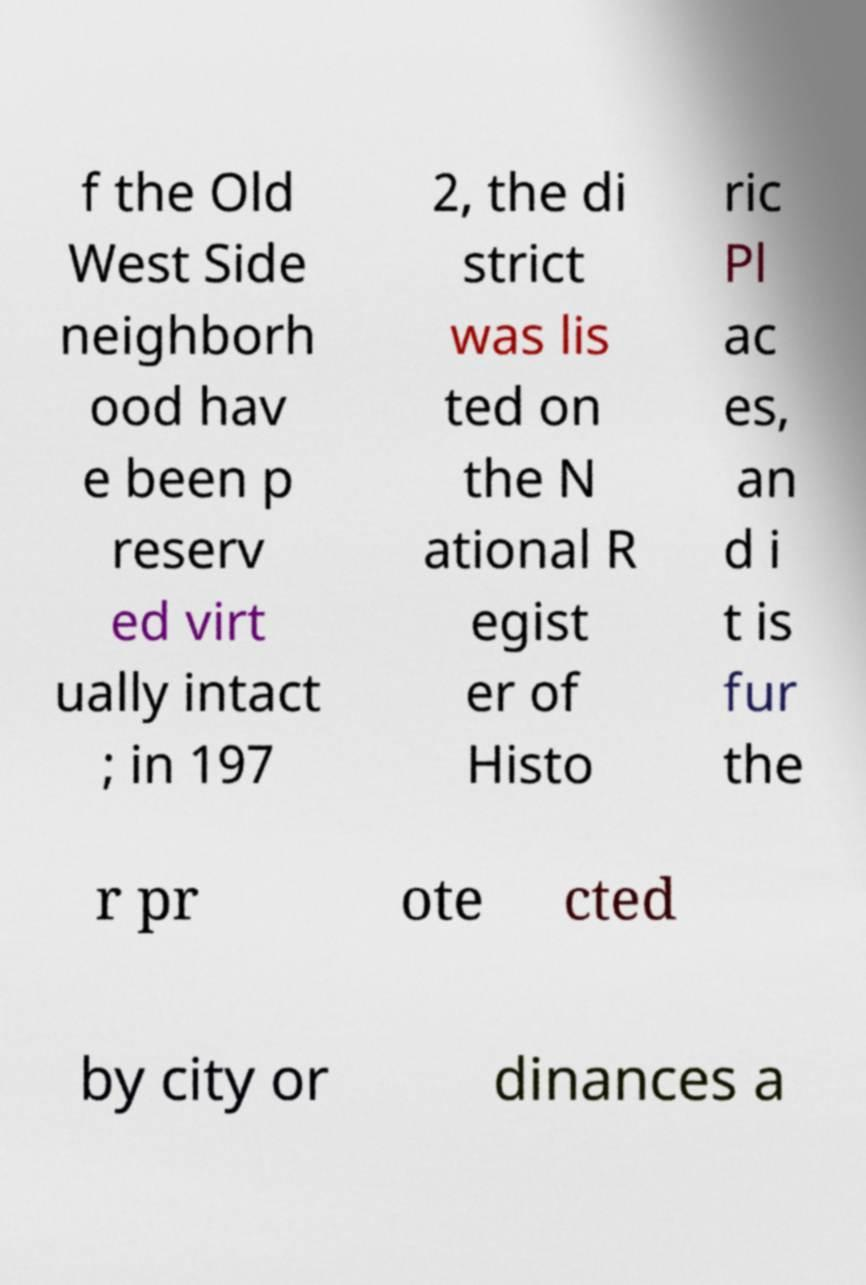Please read and relay the text visible in this image. What does it say? f the Old West Side neighborh ood hav e been p reserv ed virt ually intact ; in 197 2, the di strict was lis ted on the N ational R egist er of Histo ric Pl ac es, an d i t is fur the r pr ote cted by city or dinances a 